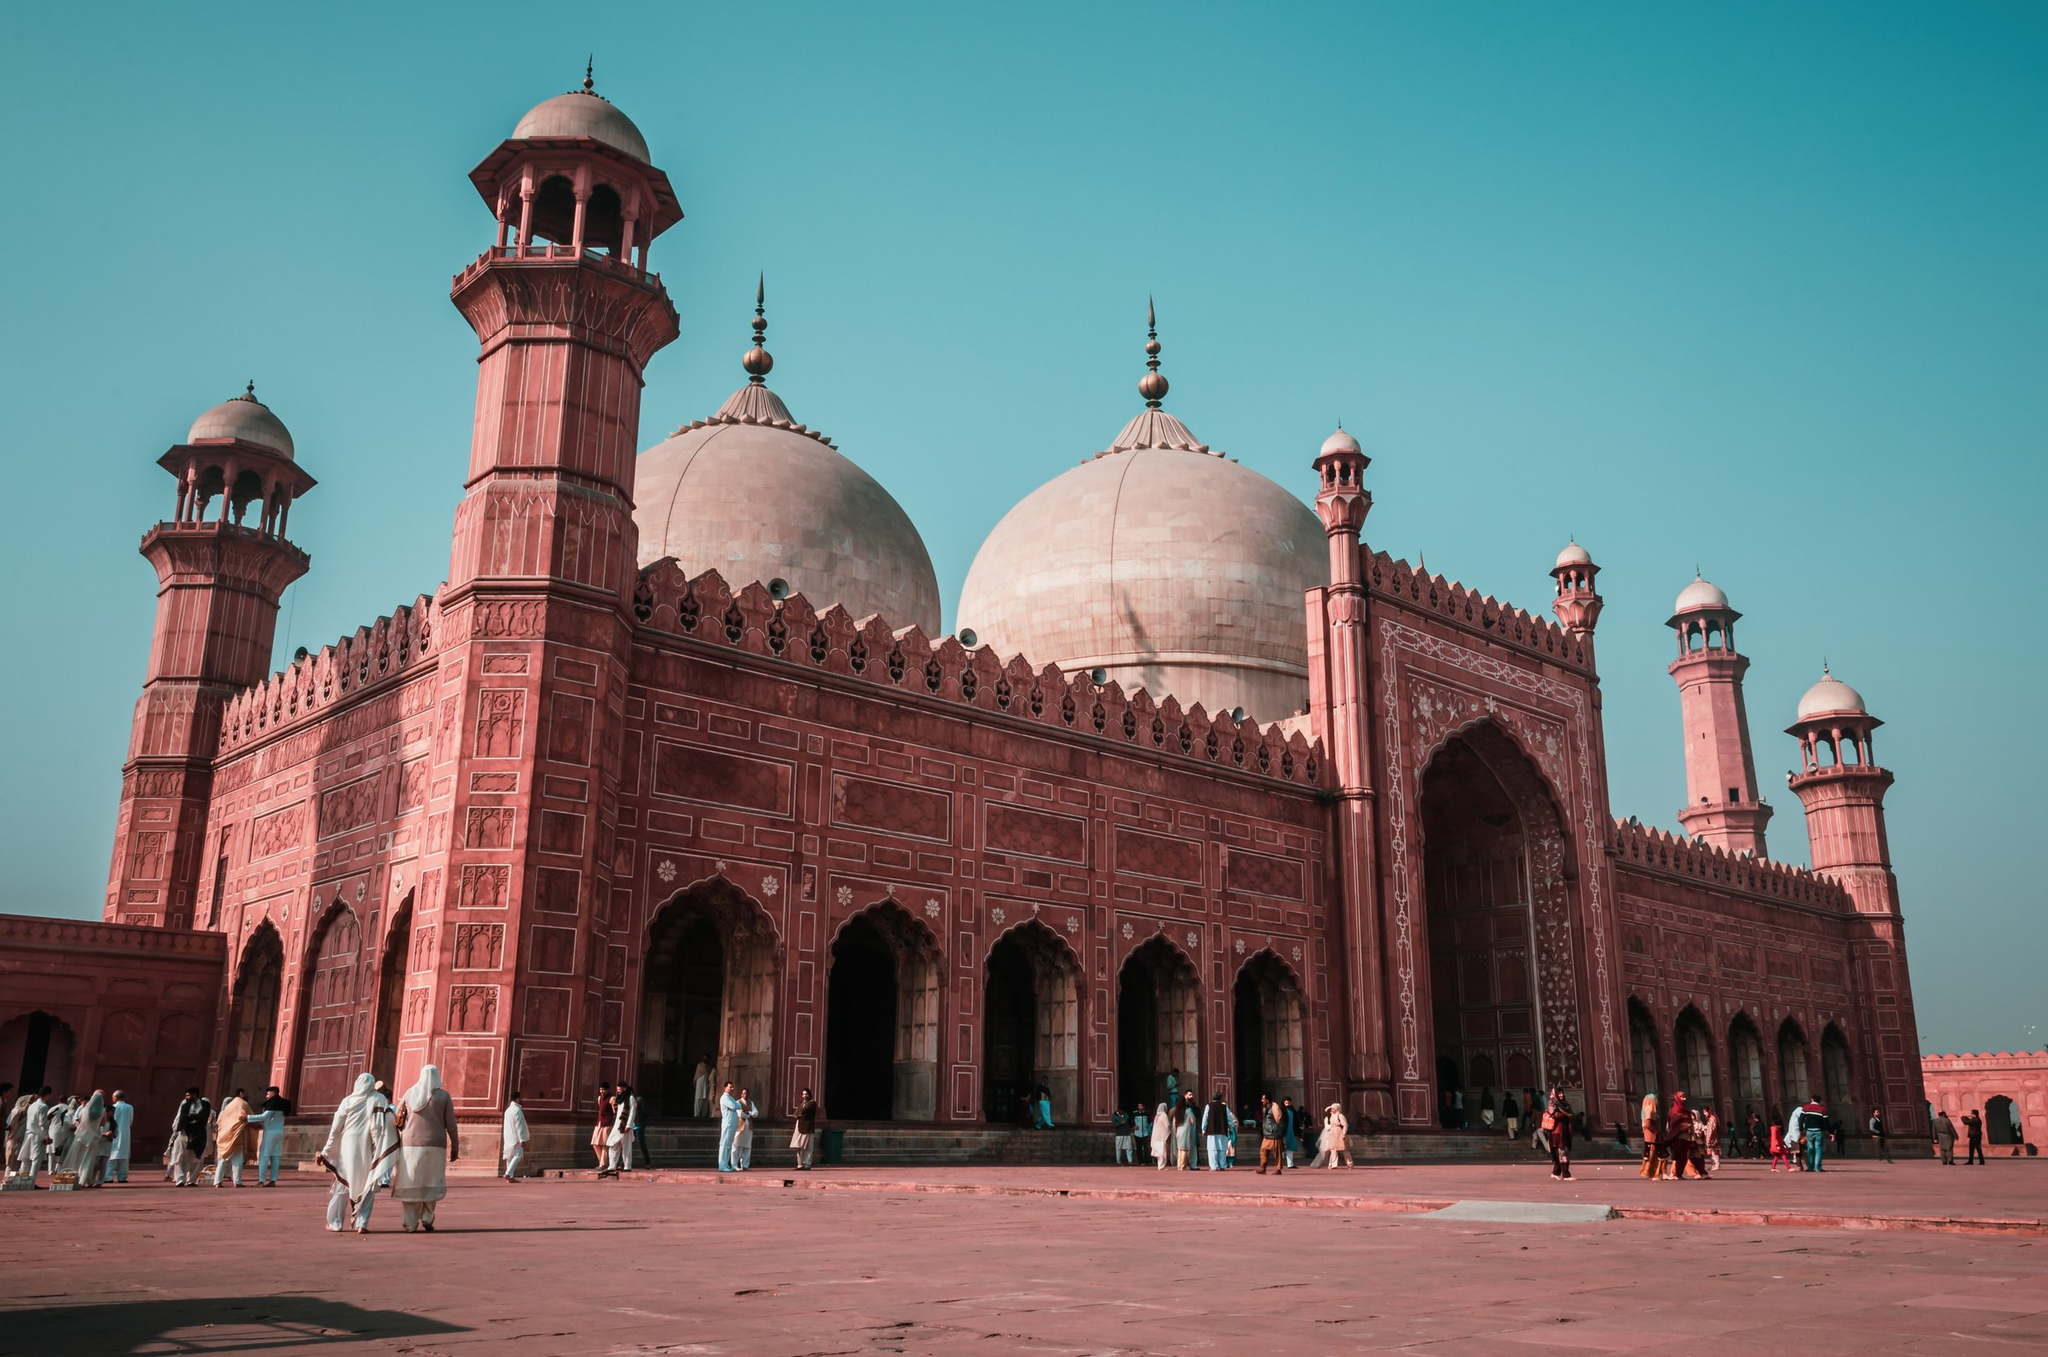What do you think is going on in this snapshot? The image captures the majestic Badshahi Mosque in Lahore, Pakistan, a striking example of Mughal architecture. Constructed with red sandstone and white marble domes, the mosque stands prominently against a pristine blue sky. The photograph, taken from a low angle, emphasizes the mosque's impressive stature and intricate detailing. The courtyard in the foreground is lively with people, who appear to be visitors or worshippers, adding a dynamic element to the scene. This magnificent structure not only showcases architectural grandeur but also signifies the rich cultural and historical tapestry of Lahore. 